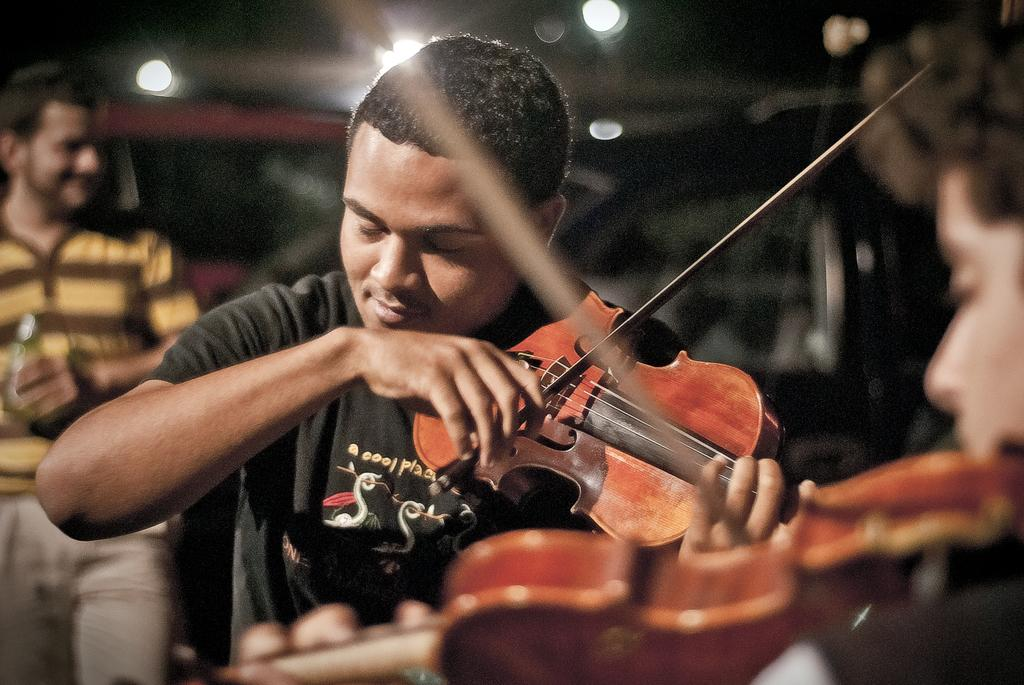What are the persons in the image doing? The persons in the image are playing a violin. Can you describe any other objects or actions in the image? One person is holding a bottle in the image. How would you describe the background of the image? The background appears blurry in the image. What type of reaction can be seen from the pigs in the image? There are no pigs present in the image, so it is not possible to determine their reactions. 